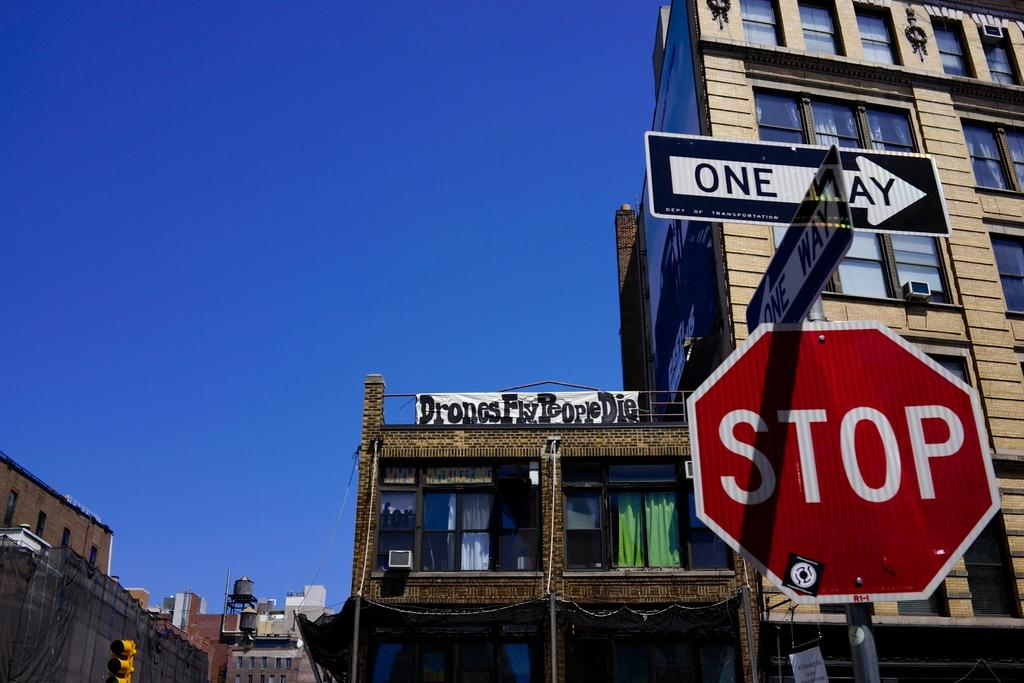<image>
Create a compact narrative representing the image presented. Someone has hung a banner saying "drones fly people die" from a balcony railing. 